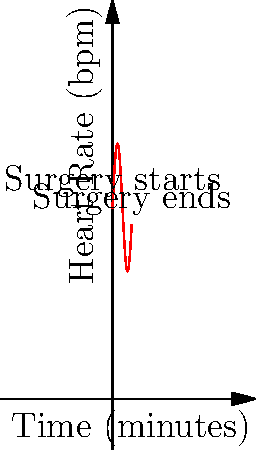During a feline spay surgery, you're monitoring the cat's heart rate. The graph shows the heart rate (in beats per minute) over time (in minutes). Calculate the average heart rate during the 6-minute procedure using the area under the curve method. Use the formula: $\text{Average} = \frac{\text{Area under the curve}}{\text{Time interval}}$. The heart rate function is given by $f(t) = 60 + 20\sin(t)$, where $t$ is time in minutes. To find the average heart rate, we need to:

1. Calculate the area under the curve (integral of the function)
2. Divide the area by the time interval

Step 1: Calculate the area under the curve
The integral of $f(t) = 60 + 20\sin(t)$ from 0 to 6 is:

$$\int_0^6 (60 + 20\sin(t)) dt = [60t - 20\cos(t)]_0^6$$

$$= (360 - 20\cos(6)) - (0 - 20\cos(0))$$
$$= 360 - 20\cos(6) + 20$$
$$= 380 - 20\cos(6)$$

Step 2: Divide by the time interval
The time interval is 6 minutes, so the average heart rate is:

$$\text{Average} = \frac{380 - 20\cos(6)}{6}$$

$$= \frac{380}{6} - \frac{20\cos(6)}{6}$$

$$\approx 63.33 - (-3.28) \approx 66.61$$

Therefore, the average heart rate during the surgery is approximately 66.61 beats per minute.
Answer: 66.61 bpm 